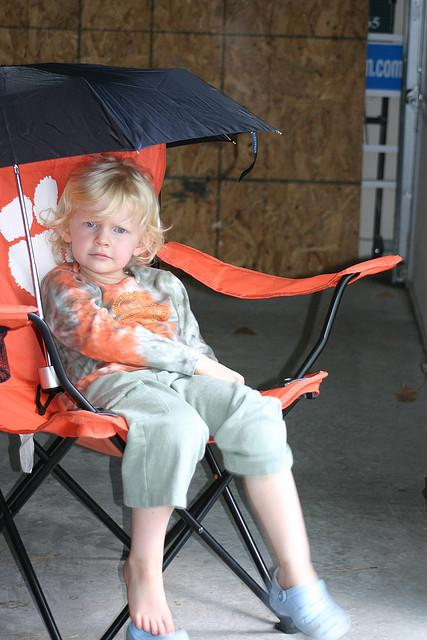What type of footwear is the boy wearing?

Choices:
A) sneakers
B) sandals
C) converse
D) crocs crocs 